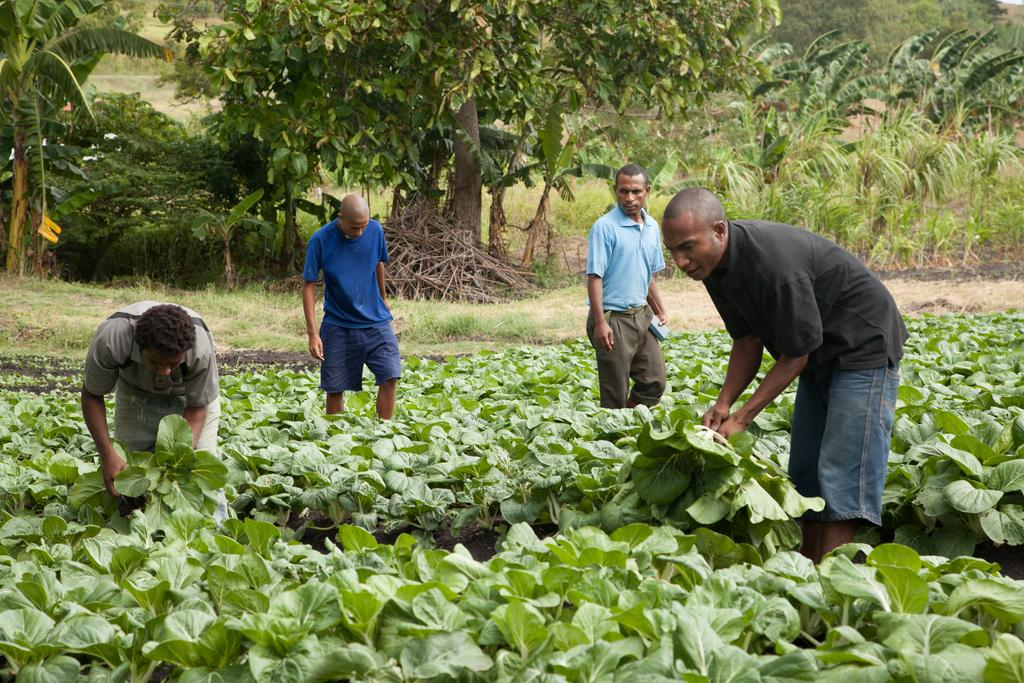How many men are present in the image? There are four men standing on the ground in the image. What are two of the men holding? Two men are holding leaves in the image. Is there anything being held by the other two men? Yes, one man is holding an object. What can be seen in the background of the image? There are trees and grass in the background of the image. What type of plastic is visible in the image? There is no plastic visible in the image. How many slaves are present in the image? The term "slave" is not applicable to the image, as it features four men standing on the ground. 